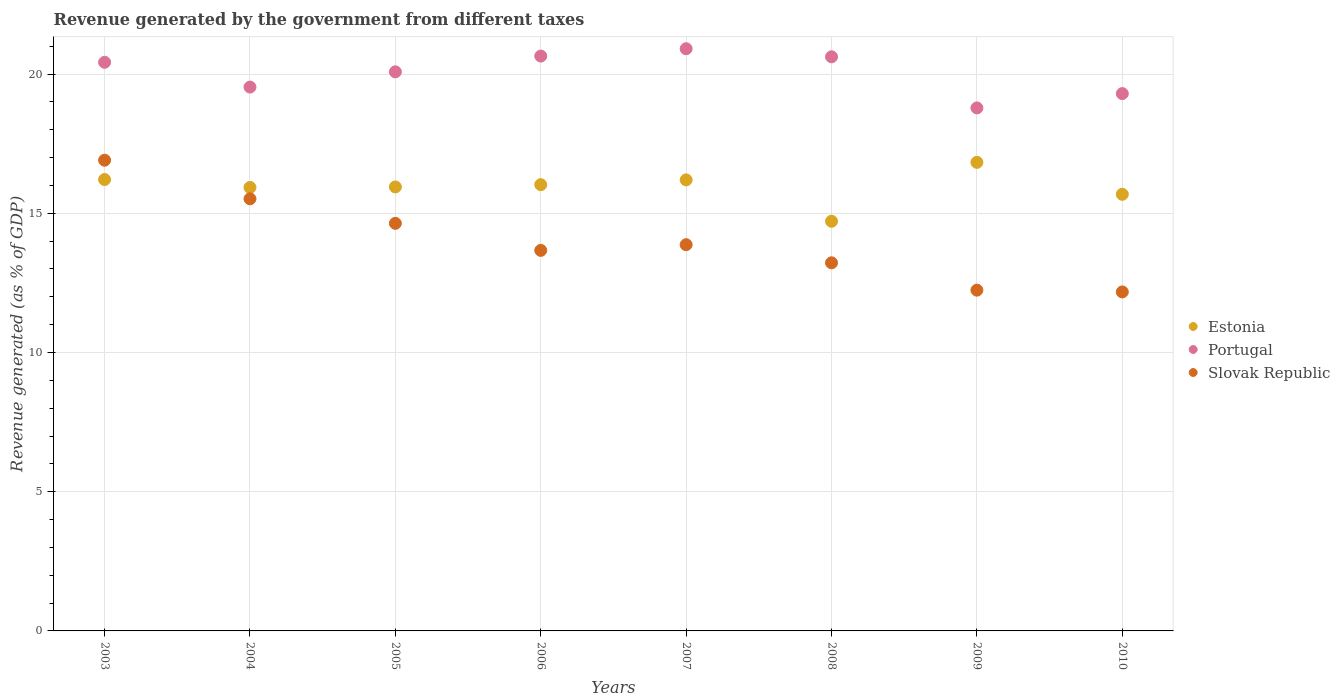What is the revenue generated by the government in Slovak Republic in 2005?
Give a very brief answer. 14.64. Across all years, what is the maximum revenue generated by the government in Portugal?
Provide a short and direct response. 20.91. Across all years, what is the minimum revenue generated by the government in Slovak Republic?
Offer a very short reply. 12.17. In which year was the revenue generated by the government in Portugal minimum?
Give a very brief answer. 2009. What is the total revenue generated by the government in Slovak Republic in the graph?
Provide a succinct answer. 112.23. What is the difference between the revenue generated by the government in Estonia in 2005 and that in 2007?
Give a very brief answer. -0.25. What is the difference between the revenue generated by the government in Estonia in 2004 and the revenue generated by the government in Slovak Republic in 2005?
Offer a terse response. 1.29. What is the average revenue generated by the government in Portugal per year?
Give a very brief answer. 20.03. In the year 2009, what is the difference between the revenue generated by the government in Slovak Republic and revenue generated by the government in Estonia?
Your answer should be compact. -4.59. What is the ratio of the revenue generated by the government in Slovak Republic in 2006 to that in 2008?
Provide a short and direct response. 1.03. What is the difference between the highest and the second highest revenue generated by the government in Portugal?
Your answer should be compact. 0.26. What is the difference between the highest and the lowest revenue generated by the government in Slovak Republic?
Ensure brevity in your answer.  4.73. In how many years, is the revenue generated by the government in Slovak Republic greater than the average revenue generated by the government in Slovak Republic taken over all years?
Offer a terse response. 3. Is it the case that in every year, the sum of the revenue generated by the government in Slovak Republic and revenue generated by the government in Estonia  is greater than the revenue generated by the government in Portugal?
Give a very brief answer. Yes. Does the revenue generated by the government in Slovak Republic monotonically increase over the years?
Ensure brevity in your answer.  No. How many years are there in the graph?
Offer a very short reply. 8. How many legend labels are there?
Provide a succinct answer. 3. How are the legend labels stacked?
Make the answer very short. Vertical. What is the title of the graph?
Ensure brevity in your answer.  Revenue generated by the government from different taxes. Does "Costa Rica" appear as one of the legend labels in the graph?
Your response must be concise. No. What is the label or title of the Y-axis?
Your answer should be compact. Revenue generated (as % of GDP). What is the Revenue generated (as % of GDP) of Estonia in 2003?
Offer a terse response. 16.21. What is the Revenue generated (as % of GDP) of Portugal in 2003?
Offer a terse response. 20.42. What is the Revenue generated (as % of GDP) of Slovak Republic in 2003?
Your answer should be compact. 16.9. What is the Revenue generated (as % of GDP) of Estonia in 2004?
Your answer should be very brief. 15.93. What is the Revenue generated (as % of GDP) in Portugal in 2004?
Provide a succinct answer. 19.53. What is the Revenue generated (as % of GDP) of Slovak Republic in 2004?
Your answer should be compact. 15.52. What is the Revenue generated (as % of GDP) of Estonia in 2005?
Your answer should be very brief. 15.94. What is the Revenue generated (as % of GDP) in Portugal in 2005?
Your response must be concise. 20.08. What is the Revenue generated (as % of GDP) of Slovak Republic in 2005?
Provide a short and direct response. 14.64. What is the Revenue generated (as % of GDP) in Estonia in 2006?
Provide a succinct answer. 16.03. What is the Revenue generated (as % of GDP) in Portugal in 2006?
Keep it short and to the point. 20.64. What is the Revenue generated (as % of GDP) in Slovak Republic in 2006?
Make the answer very short. 13.67. What is the Revenue generated (as % of GDP) of Estonia in 2007?
Offer a terse response. 16.2. What is the Revenue generated (as % of GDP) in Portugal in 2007?
Offer a very short reply. 20.91. What is the Revenue generated (as % of GDP) in Slovak Republic in 2007?
Provide a short and direct response. 13.87. What is the Revenue generated (as % of GDP) in Estonia in 2008?
Give a very brief answer. 14.71. What is the Revenue generated (as % of GDP) of Portugal in 2008?
Offer a very short reply. 20.62. What is the Revenue generated (as % of GDP) of Slovak Republic in 2008?
Your answer should be very brief. 13.22. What is the Revenue generated (as % of GDP) in Estonia in 2009?
Ensure brevity in your answer.  16.83. What is the Revenue generated (as % of GDP) of Portugal in 2009?
Offer a terse response. 18.78. What is the Revenue generated (as % of GDP) of Slovak Republic in 2009?
Your answer should be very brief. 12.24. What is the Revenue generated (as % of GDP) in Estonia in 2010?
Provide a succinct answer. 15.68. What is the Revenue generated (as % of GDP) in Portugal in 2010?
Your answer should be compact. 19.3. What is the Revenue generated (as % of GDP) in Slovak Republic in 2010?
Offer a very short reply. 12.17. Across all years, what is the maximum Revenue generated (as % of GDP) in Estonia?
Provide a succinct answer. 16.83. Across all years, what is the maximum Revenue generated (as % of GDP) of Portugal?
Provide a short and direct response. 20.91. Across all years, what is the maximum Revenue generated (as % of GDP) in Slovak Republic?
Provide a short and direct response. 16.9. Across all years, what is the minimum Revenue generated (as % of GDP) of Estonia?
Provide a short and direct response. 14.71. Across all years, what is the minimum Revenue generated (as % of GDP) in Portugal?
Provide a succinct answer. 18.78. Across all years, what is the minimum Revenue generated (as % of GDP) of Slovak Republic?
Make the answer very short. 12.17. What is the total Revenue generated (as % of GDP) in Estonia in the graph?
Your response must be concise. 127.52. What is the total Revenue generated (as % of GDP) of Portugal in the graph?
Provide a succinct answer. 160.28. What is the total Revenue generated (as % of GDP) in Slovak Republic in the graph?
Your answer should be very brief. 112.23. What is the difference between the Revenue generated (as % of GDP) of Estonia in 2003 and that in 2004?
Make the answer very short. 0.28. What is the difference between the Revenue generated (as % of GDP) of Portugal in 2003 and that in 2004?
Provide a succinct answer. 0.89. What is the difference between the Revenue generated (as % of GDP) in Slovak Republic in 2003 and that in 2004?
Your answer should be compact. 1.39. What is the difference between the Revenue generated (as % of GDP) in Estonia in 2003 and that in 2005?
Give a very brief answer. 0.27. What is the difference between the Revenue generated (as % of GDP) of Portugal in 2003 and that in 2005?
Give a very brief answer. 0.34. What is the difference between the Revenue generated (as % of GDP) of Slovak Republic in 2003 and that in 2005?
Your answer should be compact. 2.27. What is the difference between the Revenue generated (as % of GDP) in Estonia in 2003 and that in 2006?
Ensure brevity in your answer.  0.18. What is the difference between the Revenue generated (as % of GDP) in Portugal in 2003 and that in 2006?
Make the answer very short. -0.22. What is the difference between the Revenue generated (as % of GDP) of Slovak Republic in 2003 and that in 2006?
Offer a very short reply. 3.24. What is the difference between the Revenue generated (as % of GDP) in Estonia in 2003 and that in 2007?
Offer a very short reply. 0.01. What is the difference between the Revenue generated (as % of GDP) of Portugal in 2003 and that in 2007?
Offer a very short reply. -0.49. What is the difference between the Revenue generated (as % of GDP) of Slovak Republic in 2003 and that in 2007?
Offer a terse response. 3.03. What is the difference between the Revenue generated (as % of GDP) in Estonia in 2003 and that in 2008?
Offer a terse response. 1.5. What is the difference between the Revenue generated (as % of GDP) in Portugal in 2003 and that in 2008?
Provide a succinct answer. -0.2. What is the difference between the Revenue generated (as % of GDP) of Slovak Republic in 2003 and that in 2008?
Give a very brief answer. 3.68. What is the difference between the Revenue generated (as % of GDP) of Estonia in 2003 and that in 2009?
Provide a succinct answer. -0.62. What is the difference between the Revenue generated (as % of GDP) in Portugal in 2003 and that in 2009?
Provide a short and direct response. 1.64. What is the difference between the Revenue generated (as % of GDP) of Slovak Republic in 2003 and that in 2009?
Your answer should be compact. 4.67. What is the difference between the Revenue generated (as % of GDP) in Estonia in 2003 and that in 2010?
Offer a very short reply. 0.53. What is the difference between the Revenue generated (as % of GDP) in Portugal in 2003 and that in 2010?
Offer a very short reply. 1.12. What is the difference between the Revenue generated (as % of GDP) of Slovak Republic in 2003 and that in 2010?
Give a very brief answer. 4.73. What is the difference between the Revenue generated (as % of GDP) in Estonia in 2004 and that in 2005?
Offer a very short reply. -0.02. What is the difference between the Revenue generated (as % of GDP) in Portugal in 2004 and that in 2005?
Your response must be concise. -0.55. What is the difference between the Revenue generated (as % of GDP) in Slovak Republic in 2004 and that in 2005?
Ensure brevity in your answer.  0.88. What is the difference between the Revenue generated (as % of GDP) of Estonia in 2004 and that in 2006?
Offer a terse response. -0.1. What is the difference between the Revenue generated (as % of GDP) in Portugal in 2004 and that in 2006?
Ensure brevity in your answer.  -1.11. What is the difference between the Revenue generated (as % of GDP) in Slovak Republic in 2004 and that in 2006?
Offer a very short reply. 1.85. What is the difference between the Revenue generated (as % of GDP) of Estonia in 2004 and that in 2007?
Your response must be concise. -0.27. What is the difference between the Revenue generated (as % of GDP) in Portugal in 2004 and that in 2007?
Make the answer very short. -1.38. What is the difference between the Revenue generated (as % of GDP) of Slovak Republic in 2004 and that in 2007?
Your response must be concise. 1.65. What is the difference between the Revenue generated (as % of GDP) of Estonia in 2004 and that in 2008?
Your answer should be very brief. 1.21. What is the difference between the Revenue generated (as % of GDP) in Portugal in 2004 and that in 2008?
Offer a terse response. -1.09. What is the difference between the Revenue generated (as % of GDP) of Slovak Republic in 2004 and that in 2008?
Provide a succinct answer. 2.3. What is the difference between the Revenue generated (as % of GDP) of Estonia in 2004 and that in 2009?
Make the answer very short. -0.9. What is the difference between the Revenue generated (as % of GDP) of Portugal in 2004 and that in 2009?
Offer a very short reply. 0.75. What is the difference between the Revenue generated (as % of GDP) of Slovak Republic in 2004 and that in 2009?
Provide a short and direct response. 3.28. What is the difference between the Revenue generated (as % of GDP) in Estonia in 2004 and that in 2010?
Make the answer very short. 0.25. What is the difference between the Revenue generated (as % of GDP) of Portugal in 2004 and that in 2010?
Your answer should be very brief. 0.23. What is the difference between the Revenue generated (as % of GDP) in Slovak Republic in 2004 and that in 2010?
Provide a succinct answer. 3.34. What is the difference between the Revenue generated (as % of GDP) of Estonia in 2005 and that in 2006?
Provide a short and direct response. -0.08. What is the difference between the Revenue generated (as % of GDP) in Portugal in 2005 and that in 2006?
Your answer should be very brief. -0.57. What is the difference between the Revenue generated (as % of GDP) of Slovak Republic in 2005 and that in 2006?
Offer a terse response. 0.97. What is the difference between the Revenue generated (as % of GDP) in Estonia in 2005 and that in 2007?
Keep it short and to the point. -0.25. What is the difference between the Revenue generated (as % of GDP) of Portugal in 2005 and that in 2007?
Offer a very short reply. -0.83. What is the difference between the Revenue generated (as % of GDP) of Slovak Republic in 2005 and that in 2007?
Your response must be concise. 0.77. What is the difference between the Revenue generated (as % of GDP) of Estonia in 2005 and that in 2008?
Give a very brief answer. 1.23. What is the difference between the Revenue generated (as % of GDP) in Portugal in 2005 and that in 2008?
Your response must be concise. -0.54. What is the difference between the Revenue generated (as % of GDP) of Slovak Republic in 2005 and that in 2008?
Give a very brief answer. 1.42. What is the difference between the Revenue generated (as % of GDP) of Estonia in 2005 and that in 2009?
Your answer should be compact. -0.88. What is the difference between the Revenue generated (as % of GDP) of Portugal in 2005 and that in 2009?
Keep it short and to the point. 1.3. What is the difference between the Revenue generated (as % of GDP) of Slovak Republic in 2005 and that in 2009?
Offer a terse response. 2.4. What is the difference between the Revenue generated (as % of GDP) in Estonia in 2005 and that in 2010?
Make the answer very short. 0.26. What is the difference between the Revenue generated (as % of GDP) of Portugal in 2005 and that in 2010?
Provide a succinct answer. 0.78. What is the difference between the Revenue generated (as % of GDP) of Slovak Republic in 2005 and that in 2010?
Your answer should be compact. 2.46. What is the difference between the Revenue generated (as % of GDP) of Estonia in 2006 and that in 2007?
Give a very brief answer. -0.17. What is the difference between the Revenue generated (as % of GDP) of Portugal in 2006 and that in 2007?
Your response must be concise. -0.26. What is the difference between the Revenue generated (as % of GDP) of Slovak Republic in 2006 and that in 2007?
Offer a very short reply. -0.2. What is the difference between the Revenue generated (as % of GDP) of Estonia in 2006 and that in 2008?
Your response must be concise. 1.31. What is the difference between the Revenue generated (as % of GDP) in Portugal in 2006 and that in 2008?
Keep it short and to the point. 0.03. What is the difference between the Revenue generated (as % of GDP) in Slovak Republic in 2006 and that in 2008?
Ensure brevity in your answer.  0.45. What is the difference between the Revenue generated (as % of GDP) of Estonia in 2006 and that in 2009?
Your answer should be compact. -0.8. What is the difference between the Revenue generated (as % of GDP) in Portugal in 2006 and that in 2009?
Make the answer very short. 1.86. What is the difference between the Revenue generated (as % of GDP) in Slovak Republic in 2006 and that in 2009?
Your response must be concise. 1.43. What is the difference between the Revenue generated (as % of GDP) in Estonia in 2006 and that in 2010?
Make the answer very short. 0.35. What is the difference between the Revenue generated (as % of GDP) in Portugal in 2006 and that in 2010?
Provide a short and direct response. 1.35. What is the difference between the Revenue generated (as % of GDP) of Slovak Republic in 2006 and that in 2010?
Offer a very short reply. 1.49. What is the difference between the Revenue generated (as % of GDP) in Estonia in 2007 and that in 2008?
Provide a short and direct response. 1.49. What is the difference between the Revenue generated (as % of GDP) of Portugal in 2007 and that in 2008?
Offer a terse response. 0.29. What is the difference between the Revenue generated (as % of GDP) in Slovak Republic in 2007 and that in 2008?
Offer a terse response. 0.65. What is the difference between the Revenue generated (as % of GDP) in Estonia in 2007 and that in 2009?
Give a very brief answer. -0.63. What is the difference between the Revenue generated (as % of GDP) in Portugal in 2007 and that in 2009?
Keep it short and to the point. 2.13. What is the difference between the Revenue generated (as % of GDP) in Slovak Republic in 2007 and that in 2009?
Your answer should be very brief. 1.63. What is the difference between the Revenue generated (as % of GDP) in Estonia in 2007 and that in 2010?
Keep it short and to the point. 0.52. What is the difference between the Revenue generated (as % of GDP) in Portugal in 2007 and that in 2010?
Your answer should be very brief. 1.61. What is the difference between the Revenue generated (as % of GDP) in Slovak Republic in 2007 and that in 2010?
Offer a very short reply. 1.7. What is the difference between the Revenue generated (as % of GDP) in Estonia in 2008 and that in 2009?
Provide a succinct answer. -2.12. What is the difference between the Revenue generated (as % of GDP) in Portugal in 2008 and that in 2009?
Keep it short and to the point. 1.84. What is the difference between the Revenue generated (as % of GDP) of Slovak Republic in 2008 and that in 2009?
Offer a terse response. 0.98. What is the difference between the Revenue generated (as % of GDP) of Estonia in 2008 and that in 2010?
Provide a succinct answer. -0.97. What is the difference between the Revenue generated (as % of GDP) in Portugal in 2008 and that in 2010?
Offer a very short reply. 1.32. What is the difference between the Revenue generated (as % of GDP) of Slovak Republic in 2008 and that in 2010?
Provide a succinct answer. 1.05. What is the difference between the Revenue generated (as % of GDP) in Estonia in 2009 and that in 2010?
Offer a terse response. 1.15. What is the difference between the Revenue generated (as % of GDP) in Portugal in 2009 and that in 2010?
Offer a terse response. -0.51. What is the difference between the Revenue generated (as % of GDP) in Slovak Republic in 2009 and that in 2010?
Make the answer very short. 0.06. What is the difference between the Revenue generated (as % of GDP) of Estonia in 2003 and the Revenue generated (as % of GDP) of Portugal in 2004?
Make the answer very short. -3.32. What is the difference between the Revenue generated (as % of GDP) in Estonia in 2003 and the Revenue generated (as % of GDP) in Slovak Republic in 2004?
Offer a very short reply. 0.69. What is the difference between the Revenue generated (as % of GDP) of Portugal in 2003 and the Revenue generated (as % of GDP) of Slovak Republic in 2004?
Your answer should be very brief. 4.9. What is the difference between the Revenue generated (as % of GDP) in Estonia in 2003 and the Revenue generated (as % of GDP) in Portugal in 2005?
Your response must be concise. -3.87. What is the difference between the Revenue generated (as % of GDP) of Estonia in 2003 and the Revenue generated (as % of GDP) of Slovak Republic in 2005?
Your answer should be very brief. 1.57. What is the difference between the Revenue generated (as % of GDP) of Portugal in 2003 and the Revenue generated (as % of GDP) of Slovak Republic in 2005?
Keep it short and to the point. 5.78. What is the difference between the Revenue generated (as % of GDP) of Estonia in 2003 and the Revenue generated (as % of GDP) of Portugal in 2006?
Offer a very short reply. -4.43. What is the difference between the Revenue generated (as % of GDP) in Estonia in 2003 and the Revenue generated (as % of GDP) in Slovak Republic in 2006?
Provide a short and direct response. 2.54. What is the difference between the Revenue generated (as % of GDP) in Portugal in 2003 and the Revenue generated (as % of GDP) in Slovak Republic in 2006?
Make the answer very short. 6.76. What is the difference between the Revenue generated (as % of GDP) of Estonia in 2003 and the Revenue generated (as % of GDP) of Portugal in 2007?
Your answer should be compact. -4.7. What is the difference between the Revenue generated (as % of GDP) of Estonia in 2003 and the Revenue generated (as % of GDP) of Slovak Republic in 2007?
Your answer should be compact. 2.34. What is the difference between the Revenue generated (as % of GDP) of Portugal in 2003 and the Revenue generated (as % of GDP) of Slovak Republic in 2007?
Your answer should be compact. 6.55. What is the difference between the Revenue generated (as % of GDP) of Estonia in 2003 and the Revenue generated (as % of GDP) of Portugal in 2008?
Provide a succinct answer. -4.41. What is the difference between the Revenue generated (as % of GDP) of Estonia in 2003 and the Revenue generated (as % of GDP) of Slovak Republic in 2008?
Ensure brevity in your answer.  2.99. What is the difference between the Revenue generated (as % of GDP) of Portugal in 2003 and the Revenue generated (as % of GDP) of Slovak Republic in 2008?
Ensure brevity in your answer.  7.2. What is the difference between the Revenue generated (as % of GDP) in Estonia in 2003 and the Revenue generated (as % of GDP) in Portugal in 2009?
Provide a succinct answer. -2.57. What is the difference between the Revenue generated (as % of GDP) of Estonia in 2003 and the Revenue generated (as % of GDP) of Slovak Republic in 2009?
Offer a very short reply. 3.97. What is the difference between the Revenue generated (as % of GDP) in Portugal in 2003 and the Revenue generated (as % of GDP) in Slovak Republic in 2009?
Offer a very short reply. 8.18. What is the difference between the Revenue generated (as % of GDP) in Estonia in 2003 and the Revenue generated (as % of GDP) in Portugal in 2010?
Provide a succinct answer. -3.09. What is the difference between the Revenue generated (as % of GDP) of Estonia in 2003 and the Revenue generated (as % of GDP) of Slovak Republic in 2010?
Your answer should be very brief. 4.04. What is the difference between the Revenue generated (as % of GDP) in Portugal in 2003 and the Revenue generated (as % of GDP) in Slovak Republic in 2010?
Make the answer very short. 8.25. What is the difference between the Revenue generated (as % of GDP) in Estonia in 2004 and the Revenue generated (as % of GDP) in Portugal in 2005?
Your answer should be compact. -4.15. What is the difference between the Revenue generated (as % of GDP) of Estonia in 2004 and the Revenue generated (as % of GDP) of Slovak Republic in 2005?
Ensure brevity in your answer.  1.29. What is the difference between the Revenue generated (as % of GDP) in Portugal in 2004 and the Revenue generated (as % of GDP) in Slovak Republic in 2005?
Give a very brief answer. 4.89. What is the difference between the Revenue generated (as % of GDP) of Estonia in 2004 and the Revenue generated (as % of GDP) of Portugal in 2006?
Make the answer very short. -4.72. What is the difference between the Revenue generated (as % of GDP) in Estonia in 2004 and the Revenue generated (as % of GDP) in Slovak Republic in 2006?
Offer a terse response. 2.26. What is the difference between the Revenue generated (as % of GDP) of Portugal in 2004 and the Revenue generated (as % of GDP) of Slovak Republic in 2006?
Offer a very short reply. 5.86. What is the difference between the Revenue generated (as % of GDP) in Estonia in 2004 and the Revenue generated (as % of GDP) in Portugal in 2007?
Your response must be concise. -4.98. What is the difference between the Revenue generated (as % of GDP) of Estonia in 2004 and the Revenue generated (as % of GDP) of Slovak Republic in 2007?
Offer a terse response. 2.06. What is the difference between the Revenue generated (as % of GDP) of Portugal in 2004 and the Revenue generated (as % of GDP) of Slovak Republic in 2007?
Offer a very short reply. 5.66. What is the difference between the Revenue generated (as % of GDP) in Estonia in 2004 and the Revenue generated (as % of GDP) in Portugal in 2008?
Make the answer very short. -4.69. What is the difference between the Revenue generated (as % of GDP) in Estonia in 2004 and the Revenue generated (as % of GDP) in Slovak Republic in 2008?
Ensure brevity in your answer.  2.71. What is the difference between the Revenue generated (as % of GDP) of Portugal in 2004 and the Revenue generated (as % of GDP) of Slovak Republic in 2008?
Provide a succinct answer. 6.31. What is the difference between the Revenue generated (as % of GDP) in Estonia in 2004 and the Revenue generated (as % of GDP) in Portugal in 2009?
Provide a short and direct response. -2.86. What is the difference between the Revenue generated (as % of GDP) of Estonia in 2004 and the Revenue generated (as % of GDP) of Slovak Republic in 2009?
Keep it short and to the point. 3.69. What is the difference between the Revenue generated (as % of GDP) in Portugal in 2004 and the Revenue generated (as % of GDP) in Slovak Republic in 2009?
Provide a succinct answer. 7.29. What is the difference between the Revenue generated (as % of GDP) in Estonia in 2004 and the Revenue generated (as % of GDP) in Portugal in 2010?
Provide a succinct answer. -3.37. What is the difference between the Revenue generated (as % of GDP) in Estonia in 2004 and the Revenue generated (as % of GDP) in Slovak Republic in 2010?
Ensure brevity in your answer.  3.75. What is the difference between the Revenue generated (as % of GDP) of Portugal in 2004 and the Revenue generated (as % of GDP) of Slovak Republic in 2010?
Your response must be concise. 7.36. What is the difference between the Revenue generated (as % of GDP) in Estonia in 2005 and the Revenue generated (as % of GDP) in Portugal in 2006?
Keep it short and to the point. -4.7. What is the difference between the Revenue generated (as % of GDP) in Estonia in 2005 and the Revenue generated (as % of GDP) in Slovak Republic in 2006?
Keep it short and to the point. 2.28. What is the difference between the Revenue generated (as % of GDP) of Portugal in 2005 and the Revenue generated (as % of GDP) of Slovak Republic in 2006?
Your response must be concise. 6.41. What is the difference between the Revenue generated (as % of GDP) in Estonia in 2005 and the Revenue generated (as % of GDP) in Portugal in 2007?
Keep it short and to the point. -4.96. What is the difference between the Revenue generated (as % of GDP) of Estonia in 2005 and the Revenue generated (as % of GDP) of Slovak Republic in 2007?
Provide a succinct answer. 2.07. What is the difference between the Revenue generated (as % of GDP) in Portugal in 2005 and the Revenue generated (as % of GDP) in Slovak Republic in 2007?
Offer a very short reply. 6.21. What is the difference between the Revenue generated (as % of GDP) of Estonia in 2005 and the Revenue generated (as % of GDP) of Portugal in 2008?
Provide a short and direct response. -4.67. What is the difference between the Revenue generated (as % of GDP) of Estonia in 2005 and the Revenue generated (as % of GDP) of Slovak Republic in 2008?
Offer a terse response. 2.72. What is the difference between the Revenue generated (as % of GDP) in Portugal in 2005 and the Revenue generated (as % of GDP) in Slovak Republic in 2008?
Offer a very short reply. 6.86. What is the difference between the Revenue generated (as % of GDP) of Estonia in 2005 and the Revenue generated (as % of GDP) of Portugal in 2009?
Provide a short and direct response. -2.84. What is the difference between the Revenue generated (as % of GDP) of Estonia in 2005 and the Revenue generated (as % of GDP) of Slovak Republic in 2009?
Make the answer very short. 3.71. What is the difference between the Revenue generated (as % of GDP) in Portugal in 2005 and the Revenue generated (as % of GDP) in Slovak Republic in 2009?
Give a very brief answer. 7.84. What is the difference between the Revenue generated (as % of GDP) of Estonia in 2005 and the Revenue generated (as % of GDP) of Portugal in 2010?
Your answer should be very brief. -3.35. What is the difference between the Revenue generated (as % of GDP) of Estonia in 2005 and the Revenue generated (as % of GDP) of Slovak Republic in 2010?
Give a very brief answer. 3.77. What is the difference between the Revenue generated (as % of GDP) in Portugal in 2005 and the Revenue generated (as % of GDP) in Slovak Republic in 2010?
Make the answer very short. 7.9. What is the difference between the Revenue generated (as % of GDP) of Estonia in 2006 and the Revenue generated (as % of GDP) of Portugal in 2007?
Offer a terse response. -4.88. What is the difference between the Revenue generated (as % of GDP) in Estonia in 2006 and the Revenue generated (as % of GDP) in Slovak Republic in 2007?
Keep it short and to the point. 2.16. What is the difference between the Revenue generated (as % of GDP) in Portugal in 2006 and the Revenue generated (as % of GDP) in Slovak Republic in 2007?
Your answer should be compact. 6.77. What is the difference between the Revenue generated (as % of GDP) of Estonia in 2006 and the Revenue generated (as % of GDP) of Portugal in 2008?
Make the answer very short. -4.59. What is the difference between the Revenue generated (as % of GDP) of Estonia in 2006 and the Revenue generated (as % of GDP) of Slovak Republic in 2008?
Give a very brief answer. 2.81. What is the difference between the Revenue generated (as % of GDP) of Portugal in 2006 and the Revenue generated (as % of GDP) of Slovak Republic in 2008?
Your answer should be compact. 7.42. What is the difference between the Revenue generated (as % of GDP) in Estonia in 2006 and the Revenue generated (as % of GDP) in Portugal in 2009?
Provide a succinct answer. -2.76. What is the difference between the Revenue generated (as % of GDP) in Estonia in 2006 and the Revenue generated (as % of GDP) in Slovak Republic in 2009?
Provide a short and direct response. 3.79. What is the difference between the Revenue generated (as % of GDP) of Portugal in 2006 and the Revenue generated (as % of GDP) of Slovak Republic in 2009?
Your answer should be compact. 8.41. What is the difference between the Revenue generated (as % of GDP) in Estonia in 2006 and the Revenue generated (as % of GDP) in Portugal in 2010?
Your response must be concise. -3.27. What is the difference between the Revenue generated (as % of GDP) in Estonia in 2006 and the Revenue generated (as % of GDP) in Slovak Republic in 2010?
Your answer should be very brief. 3.85. What is the difference between the Revenue generated (as % of GDP) in Portugal in 2006 and the Revenue generated (as % of GDP) in Slovak Republic in 2010?
Make the answer very short. 8.47. What is the difference between the Revenue generated (as % of GDP) of Estonia in 2007 and the Revenue generated (as % of GDP) of Portugal in 2008?
Make the answer very short. -4.42. What is the difference between the Revenue generated (as % of GDP) of Estonia in 2007 and the Revenue generated (as % of GDP) of Slovak Republic in 2008?
Provide a short and direct response. 2.98. What is the difference between the Revenue generated (as % of GDP) in Portugal in 2007 and the Revenue generated (as % of GDP) in Slovak Republic in 2008?
Offer a very short reply. 7.69. What is the difference between the Revenue generated (as % of GDP) in Estonia in 2007 and the Revenue generated (as % of GDP) in Portugal in 2009?
Provide a short and direct response. -2.58. What is the difference between the Revenue generated (as % of GDP) in Estonia in 2007 and the Revenue generated (as % of GDP) in Slovak Republic in 2009?
Ensure brevity in your answer.  3.96. What is the difference between the Revenue generated (as % of GDP) of Portugal in 2007 and the Revenue generated (as % of GDP) of Slovak Republic in 2009?
Give a very brief answer. 8.67. What is the difference between the Revenue generated (as % of GDP) in Estonia in 2007 and the Revenue generated (as % of GDP) in Portugal in 2010?
Offer a terse response. -3.1. What is the difference between the Revenue generated (as % of GDP) in Estonia in 2007 and the Revenue generated (as % of GDP) in Slovak Republic in 2010?
Your answer should be compact. 4.02. What is the difference between the Revenue generated (as % of GDP) of Portugal in 2007 and the Revenue generated (as % of GDP) of Slovak Republic in 2010?
Your answer should be compact. 8.73. What is the difference between the Revenue generated (as % of GDP) in Estonia in 2008 and the Revenue generated (as % of GDP) in Portugal in 2009?
Your answer should be compact. -4.07. What is the difference between the Revenue generated (as % of GDP) of Estonia in 2008 and the Revenue generated (as % of GDP) of Slovak Republic in 2009?
Give a very brief answer. 2.47. What is the difference between the Revenue generated (as % of GDP) in Portugal in 2008 and the Revenue generated (as % of GDP) in Slovak Republic in 2009?
Your answer should be compact. 8.38. What is the difference between the Revenue generated (as % of GDP) in Estonia in 2008 and the Revenue generated (as % of GDP) in Portugal in 2010?
Keep it short and to the point. -4.59. What is the difference between the Revenue generated (as % of GDP) of Estonia in 2008 and the Revenue generated (as % of GDP) of Slovak Republic in 2010?
Offer a terse response. 2.54. What is the difference between the Revenue generated (as % of GDP) in Portugal in 2008 and the Revenue generated (as % of GDP) in Slovak Republic in 2010?
Your answer should be compact. 8.44. What is the difference between the Revenue generated (as % of GDP) of Estonia in 2009 and the Revenue generated (as % of GDP) of Portugal in 2010?
Ensure brevity in your answer.  -2.47. What is the difference between the Revenue generated (as % of GDP) of Estonia in 2009 and the Revenue generated (as % of GDP) of Slovak Republic in 2010?
Your response must be concise. 4.65. What is the difference between the Revenue generated (as % of GDP) of Portugal in 2009 and the Revenue generated (as % of GDP) of Slovak Republic in 2010?
Offer a very short reply. 6.61. What is the average Revenue generated (as % of GDP) of Estonia per year?
Offer a terse response. 15.94. What is the average Revenue generated (as % of GDP) in Portugal per year?
Your answer should be very brief. 20.03. What is the average Revenue generated (as % of GDP) in Slovak Republic per year?
Your response must be concise. 14.03. In the year 2003, what is the difference between the Revenue generated (as % of GDP) in Estonia and Revenue generated (as % of GDP) in Portugal?
Your answer should be compact. -4.21. In the year 2003, what is the difference between the Revenue generated (as % of GDP) in Estonia and Revenue generated (as % of GDP) in Slovak Republic?
Your answer should be very brief. -0.69. In the year 2003, what is the difference between the Revenue generated (as % of GDP) of Portugal and Revenue generated (as % of GDP) of Slovak Republic?
Offer a terse response. 3.52. In the year 2004, what is the difference between the Revenue generated (as % of GDP) of Estonia and Revenue generated (as % of GDP) of Portugal?
Offer a terse response. -3.6. In the year 2004, what is the difference between the Revenue generated (as % of GDP) in Estonia and Revenue generated (as % of GDP) in Slovak Republic?
Ensure brevity in your answer.  0.41. In the year 2004, what is the difference between the Revenue generated (as % of GDP) in Portugal and Revenue generated (as % of GDP) in Slovak Republic?
Keep it short and to the point. 4.01. In the year 2005, what is the difference between the Revenue generated (as % of GDP) of Estonia and Revenue generated (as % of GDP) of Portugal?
Your answer should be very brief. -4.13. In the year 2005, what is the difference between the Revenue generated (as % of GDP) of Estonia and Revenue generated (as % of GDP) of Slovak Republic?
Your response must be concise. 1.31. In the year 2005, what is the difference between the Revenue generated (as % of GDP) of Portugal and Revenue generated (as % of GDP) of Slovak Republic?
Keep it short and to the point. 5.44. In the year 2006, what is the difference between the Revenue generated (as % of GDP) of Estonia and Revenue generated (as % of GDP) of Portugal?
Your response must be concise. -4.62. In the year 2006, what is the difference between the Revenue generated (as % of GDP) in Estonia and Revenue generated (as % of GDP) in Slovak Republic?
Your answer should be compact. 2.36. In the year 2006, what is the difference between the Revenue generated (as % of GDP) in Portugal and Revenue generated (as % of GDP) in Slovak Republic?
Offer a terse response. 6.98. In the year 2007, what is the difference between the Revenue generated (as % of GDP) in Estonia and Revenue generated (as % of GDP) in Portugal?
Ensure brevity in your answer.  -4.71. In the year 2007, what is the difference between the Revenue generated (as % of GDP) of Estonia and Revenue generated (as % of GDP) of Slovak Republic?
Keep it short and to the point. 2.33. In the year 2007, what is the difference between the Revenue generated (as % of GDP) of Portugal and Revenue generated (as % of GDP) of Slovak Republic?
Provide a succinct answer. 7.04. In the year 2008, what is the difference between the Revenue generated (as % of GDP) in Estonia and Revenue generated (as % of GDP) in Portugal?
Offer a terse response. -5.91. In the year 2008, what is the difference between the Revenue generated (as % of GDP) of Estonia and Revenue generated (as % of GDP) of Slovak Republic?
Provide a short and direct response. 1.49. In the year 2008, what is the difference between the Revenue generated (as % of GDP) in Portugal and Revenue generated (as % of GDP) in Slovak Republic?
Provide a short and direct response. 7.4. In the year 2009, what is the difference between the Revenue generated (as % of GDP) of Estonia and Revenue generated (as % of GDP) of Portugal?
Provide a succinct answer. -1.95. In the year 2009, what is the difference between the Revenue generated (as % of GDP) in Estonia and Revenue generated (as % of GDP) in Slovak Republic?
Ensure brevity in your answer.  4.59. In the year 2009, what is the difference between the Revenue generated (as % of GDP) of Portugal and Revenue generated (as % of GDP) of Slovak Republic?
Offer a very short reply. 6.54. In the year 2010, what is the difference between the Revenue generated (as % of GDP) of Estonia and Revenue generated (as % of GDP) of Portugal?
Your answer should be compact. -3.62. In the year 2010, what is the difference between the Revenue generated (as % of GDP) of Estonia and Revenue generated (as % of GDP) of Slovak Republic?
Keep it short and to the point. 3.51. In the year 2010, what is the difference between the Revenue generated (as % of GDP) in Portugal and Revenue generated (as % of GDP) in Slovak Republic?
Your answer should be very brief. 7.12. What is the ratio of the Revenue generated (as % of GDP) in Estonia in 2003 to that in 2004?
Provide a succinct answer. 1.02. What is the ratio of the Revenue generated (as % of GDP) in Portugal in 2003 to that in 2004?
Your answer should be very brief. 1.05. What is the ratio of the Revenue generated (as % of GDP) of Slovak Republic in 2003 to that in 2004?
Provide a short and direct response. 1.09. What is the ratio of the Revenue generated (as % of GDP) of Estonia in 2003 to that in 2005?
Provide a short and direct response. 1.02. What is the ratio of the Revenue generated (as % of GDP) in Portugal in 2003 to that in 2005?
Your answer should be very brief. 1.02. What is the ratio of the Revenue generated (as % of GDP) of Slovak Republic in 2003 to that in 2005?
Keep it short and to the point. 1.15. What is the ratio of the Revenue generated (as % of GDP) of Estonia in 2003 to that in 2006?
Give a very brief answer. 1.01. What is the ratio of the Revenue generated (as % of GDP) in Portugal in 2003 to that in 2006?
Ensure brevity in your answer.  0.99. What is the ratio of the Revenue generated (as % of GDP) in Slovak Republic in 2003 to that in 2006?
Keep it short and to the point. 1.24. What is the ratio of the Revenue generated (as % of GDP) of Estonia in 2003 to that in 2007?
Your answer should be very brief. 1. What is the ratio of the Revenue generated (as % of GDP) in Portugal in 2003 to that in 2007?
Offer a terse response. 0.98. What is the ratio of the Revenue generated (as % of GDP) in Slovak Republic in 2003 to that in 2007?
Offer a very short reply. 1.22. What is the ratio of the Revenue generated (as % of GDP) of Estonia in 2003 to that in 2008?
Keep it short and to the point. 1.1. What is the ratio of the Revenue generated (as % of GDP) of Portugal in 2003 to that in 2008?
Provide a short and direct response. 0.99. What is the ratio of the Revenue generated (as % of GDP) in Slovak Republic in 2003 to that in 2008?
Provide a short and direct response. 1.28. What is the ratio of the Revenue generated (as % of GDP) of Estonia in 2003 to that in 2009?
Provide a succinct answer. 0.96. What is the ratio of the Revenue generated (as % of GDP) of Portugal in 2003 to that in 2009?
Your answer should be compact. 1.09. What is the ratio of the Revenue generated (as % of GDP) in Slovak Republic in 2003 to that in 2009?
Offer a terse response. 1.38. What is the ratio of the Revenue generated (as % of GDP) in Estonia in 2003 to that in 2010?
Give a very brief answer. 1.03. What is the ratio of the Revenue generated (as % of GDP) in Portugal in 2003 to that in 2010?
Your response must be concise. 1.06. What is the ratio of the Revenue generated (as % of GDP) in Slovak Republic in 2003 to that in 2010?
Provide a short and direct response. 1.39. What is the ratio of the Revenue generated (as % of GDP) in Estonia in 2004 to that in 2005?
Make the answer very short. 1. What is the ratio of the Revenue generated (as % of GDP) of Portugal in 2004 to that in 2005?
Ensure brevity in your answer.  0.97. What is the ratio of the Revenue generated (as % of GDP) of Slovak Republic in 2004 to that in 2005?
Keep it short and to the point. 1.06. What is the ratio of the Revenue generated (as % of GDP) of Portugal in 2004 to that in 2006?
Ensure brevity in your answer.  0.95. What is the ratio of the Revenue generated (as % of GDP) in Slovak Republic in 2004 to that in 2006?
Give a very brief answer. 1.14. What is the ratio of the Revenue generated (as % of GDP) of Estonia in 2004 to that in 2007?
Ensure brevity in your answer.  0.98. What is the ratio of the Revenue generated (as % of GDP) of Portugal in 2004 to that in 2007?
Offer a terse response. 0.93. What is the ratio of the Revenue generated (as % of GDP) in Slovak Republic in 2004 to that in 2007?
Offer a very short reply. 1.12. What is the ratio of the Revenue generated (as % of GDP) of Estonia in 2004 to that in 2008?
Offer a very short reply. 1.08. What is the ratio of the Revenue generated (as % of GDP) in Portugal in 2004 to that in 2008?
Your answer should be very brief. 0.95. What is the ratio of the Revenue generated (as % of GDP) of Slovak Republic in 2004 to that in 2008?
Make the answer very short. 1.17. What is the ratio of the Revenue generated (as % of GDP) of Estonia in 2004 to that in 2009?
Offer a very short reply. 0.95. What is the ratio of the Revenue generated (as % of GDP) of Portugal in 2004 to that in 2009?
Provide a short and direct response. 1.04. What is the ratio of the Revenue generated (as % of GDP) of Slovak Republic in 2004 to that in 2009?
Offer a very short reply. 1.27. What is the ratio of the Revenue generated (as % of GDP) in Estonia in 2004 to that in 2010?
Offer a very short reply. 1.02. What is the ratio of the Revenue generated (as % of GDP) in Portugal in 2004 to that in 2010?
Offer a terse response. 1.01. What is the ratio of the Revenue generated (as % of GDP) in Slovak Republic in 2004 to that in 2010?
Ensure brevity in your answer.  1.27. What is the ratio of the Revenue generated (as % of GDP) in Portugal in 2005 to that in 2006?
Make the answer very short. 0.97. What is the ratio of the Revenue generated (as % of GDP) of Slovak Republic in 2005 to that in 2006?
Make the answer very short. 1.07. What is the ratio of the Revenue generated (as % of GDP) in Estonia in 2005 to that in 2007?
Your answer should be very brief. 0.98. What is the ratio of the Revenue generated (as % of GDP) of Portugal in 2005 to that in 2007?
Give a very brief answer. 0.96. What is the ratio of the Revenue generated (as % of GDP) of Slovak Republic in 2005 to that in 2007?
Offer a very short reply. 1.06. What is the ratio of the Revenue generated (as % of GDP) of Estonia in 2005 to that in 2008?
Make the answer very short. 1.08. What is the ratio of the Revenue generated (as % of GDP) in Portugal in 2005 to that in 2008?
Provide a succinct answer. 0.97. What is the ratio of the Revenue generated (as % of GDP) in Slovak Republic in 2005 to that in 2008?
Your answer should be compact. 1.11. What is the ratio of the Revenue generated (as % of GDP) in Estonia in 2005 to that in 2009?
Make the answer very short. 0.95. What is the ratio of the Revenue generated (as % of GDP) of Portugal in 2005 to that in 2009?
Give a very brief answer. 1.07. What is the ratio of the Revenue generated (as % of GDP) in Slovak Republic in 2005 to that in 2009?
Your response must be concise. 1.2. What is the ratio of the Revenue generated (as % of GDP) of Estonia in 2005 to that in 2010?
Offer a very short reply. 1.02. What is the ratio of the Revenue generated (as % of GDP) in Portugal in 2005 to that in 2010?
Your answer should be compact. 1.04. What is the ratio of the Revenue generated (as % of GDP) in Slovak Republic in 2005 to that in 2010?
Ensure brevity in your answer.  1.2. What is the ratio of the Revenue generated (as % of GDP) of Estonia in 2006 to that in 2007?
Give a very brief answer. 0.99. What is the ratio of the Revenue generated (as % of GDP) in Portugal in 2006 to that in 2007?
Keep it short and to the point. 0.99. What is the ratio of the Revenue generated (as % of GDP) of Slovak Republic in 2006 to that in 2007?
Make the answer very short. 0.99. What is the ratio of the Revenue generated (as % of GDP) in Estonia in 2006 to that in 2008?
Provide a succinct answer. 1.09. What is the ratio of the Revenue generated (as % of GDP) in Portugal in 2006 to that in 2008?
Provide a short and direct response. 1. What is the ratio of the Revenue generated (as % of GDP) of Slovak Republic in 2006 to that in 2008?
Provide a short and direct response. 1.03. What is the ratio of the Revenue generated (as % of GDP) in Portugal in 2006 to that in 2009?
Keep it short and to the point. 1.1. What is the ratio of the Revenue generated (as % of GDP) of Slovak Republic in 2006 to that in 2009?
Offer a very short reply. 1.12. What is the ratio of the Revenue generated (as % of GDP) in Estonia in 2006 to that in 2010?
Keep it short and to the point. 1.02. What is the ratio of the Revenue generated (as % of GDP) in Portugal in 2006 to that in 2010?
Provide a short and direct response. 1.07. What is the ratio of the Revenue generated (as % of GDP) of Slovak Republic in 2006 to that in 2010?
Provide a succinct answer. 1.12. What is the ratio of the Revenue generated (as % of GDP) of Estonia in 2007 to that in 2008?
Your answer should be very brief. 1.1. What is the ratio of the Revenue generated (as % of GDP) in Slovak Republic in 2007 to that in 2008?
Your answer should be very brief. 1.05. What is the ratio of the Revenue generated (as % of GDP) in Estonia in 2007 to that in 2009?
Your response must be concise. 0.96. What is the ratio of the Revenue generated (as % of GDP) in Portugal in 2007 to that in 2009?
Your answer should be compact. 1.11. What is the ratio of the Revenue generated (as % of GDP) in Slovak Republic in 2007 to that in 2009?
Ensure brevity in your answer.  1.13. What is the ratio of the Revenue generated (as % of GDP) of Estonia in 2007 to that in 2010?
Your answer should be very brief. 1.03. What is the ratio of the Revenue generated (as % of GDP) of Portugal in 2007 to that in 2010?
Give a very brief answer. 1.08. What is the ratio of the Revenue generated (as % of GDP) in Slovak Republic in 2007 to that in 2010?
Keep it short and to the point. 1.14. What is the ratio of the Revenue generated (as % of GDP) of Estonia in 2008 to that in 2009?
Ensure brevity in your answer.  0.87. What is the ratio of the Revenue generated (as % of GDP) in Portugal in 2008 to that in 2009?
Your response must be concise. 1.1. What is the ratio of the Revenue generated (as % of GDP) of Slovak Republic in 2008 to that in 2009?
Make the answer very short. 1.08. What is the ratio of the Revenue generated (as % of GDP) in Estonia in 2008 to that in 2010?
Your answer should be compact. 0.94. What is the ratio of the Revenue generated (as % of GDP) of Portugal in 2008 to that in 2010?
Offer a terse response. 1.07. What is the ratio of the Revenue generated (as % of GDP) in Slovak Republic in 2008 to that in 2010?
Your answer should be compact. 1.09. What is the ratio of the Revenue generated (as % of GDP) in Estonia in 2009 to that in 2010?
Provide a short and direct response. 1.07. What is the ratio of the Revenue generated (as % of GDP) in Portugal in 2009 to that in 2010?
Ensure brevity in your answer.  0.97. What is the ratio of the Revenue generated (as % of GDP) in Slovak Republic in 2009 to that in 2010?
Give a very brief answer. 1.01. What is the difference between the highest and the second highest Revenue generated (as % of GDP) in Estonia?
Provide a succinct answer. 0.62. What is the difference between the highest and the second highest Revenue generated (as % of GDP) in Portugal?
Offer a very short reply. 0.26. What is the difference between the highest and the second highest Revenue generated (as % of GDP) of Slovak Republic?
Offer a terse response. 1.39. What is the difference between the highest and the lowest Revenue generated (as % of GDP) of Estonia?
Offer a terse response. 2.12. What is the difference between the highest and the lowest Revenue generated (as % of GDP) in Portugal?
Provide a succinct answer. 2.13. What is the difference between the highest and the lowest Revenue generated (as % of GDP) of Slovak Republic?
Your answer should be very brief. 4.73. 